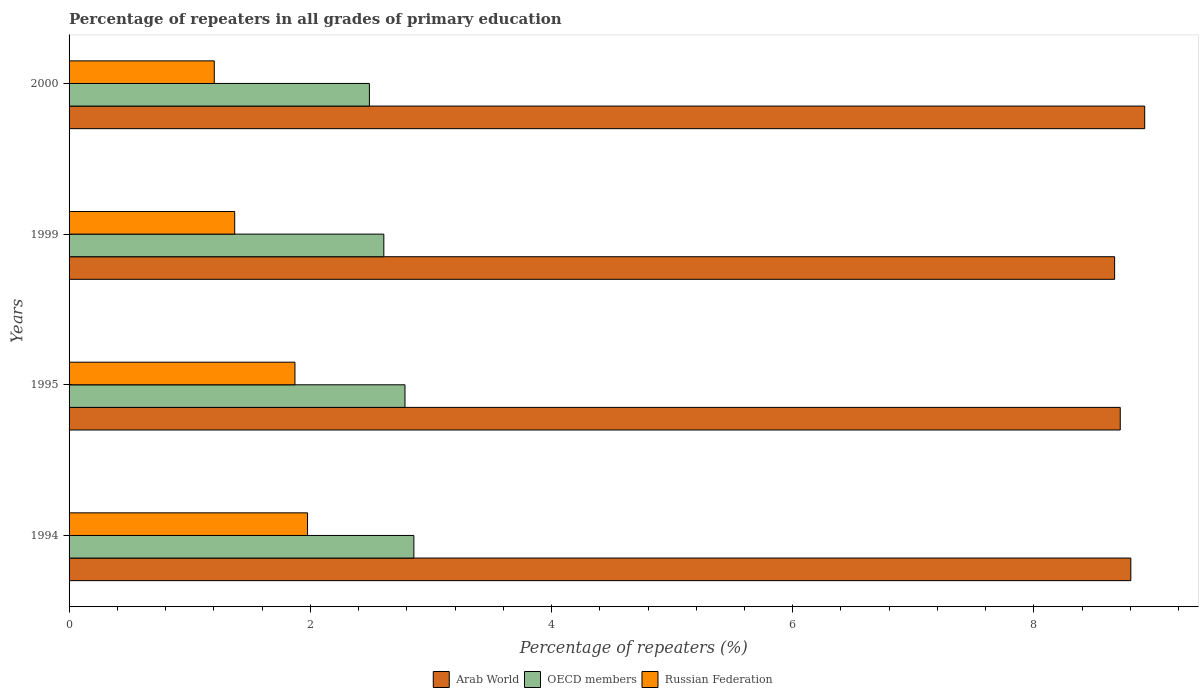How many different coloured bars are there?
Give a very brief answer. 3. Are the number of bars on each tick of the Y-axis equal?
Ensure brevity in your answer.  Yes. How many bars are there on the 1st tick from the top?
Make the answer very short. 3. How many bars are there on the 3rd tick from the bottom?
Provide a succinct answer. 3. In how many cases, is the number of bars for a given year not equal to the number of legend labels?
Give a very brief answer. 0. What is the percentage of repeaters in Arab World in 1995?
Offer a very short reply. 8.72. Across all years, what is the maximum percentage of repeaters in Russian Federation?
Provide a succinct answer. 1.98. Across all years, what is the minimum percentage of repeaters in Arab World?
Ensure brevity in your answer.  8.67. In which year was the percentage of repeaters in Russian Federation maximum?
Your answer should be very brief. 1994. What is the total percentage of repeaters in Russian Federation in the graph?
Make the answer very short. 6.43. What is the difference between the percentage of repeaters in Arab World in 1999 and that in 2000?
Your answer should be compact. -0.25. What is the difference between the percentage of repeaters in Arab World in 2000 and the percentage of repeaters in Russian Federation in 1999?
Make the answer very short. 7.54. What is the average percentage of repeaters in Arab World per year?
Ensure brevity in your answer.  8.78. In the year 2000, what is the difference between the percentage of repeaters in OECD members and percentage of repeaters in Arab World?
Offer a very short reply. -6.43. What is the ratio of the percentage of repeaters in OECD members in 1995 to that in 2000?
Offer a very short reply. 1.12. Is the percentage of repeaters in Russian Federation in 1999 less than that in 2000?
Your response must be concise. No. What is the difference between the highest and the second highest percentage of repeaters in OECD members?
Provide a short and direct response. 0.07. What is the difference between the highest and the lowest percentage of repeaters in Arab World?
Keep it short and to the point. 0.25. In how many years, is the percentage of repeaters in Russian Federation greater than the average percentage of repeaters in Russian Federation taken over all years?
Provide a succinct answer. 2. What does the 1st bar from the top in 1995 represents?
Provide a short and direct response. Russian Federation. What does the 3rd bar from the bottom in 1994 represents?
Your answer should be very brief. Russian Federation. Are all the bars in the graph horizontal?
Your answer should be very brief. Yes. How many years are there in the graph?
Offer a very short reply. 4. Does the graph contain any zero values?
Offer a very short reply. No. Does the graph contain grids?
Make the answer very short. No. Where does the legend appear in the graph?
Ensure brevity in your answer.  Bottom center. How are the legend labels stacked?
Your response must be concise. Horizontal. What is the title of the graph?
Provide a short and direct response. Percentage of repeaters in all grades of primary education. What is the label or title of the X-axis?
Make the answer very short. Percentage of repeaters (%). What is the label or title of the Y-axis?
Provide a succinct answer. Years. What is the Percentage of repeaters (%) of Arab World in 1994?
Provide a succinct answer. 8.8. What is the Percentage of repeaters (%) in OECD members in 1994?
Give a very brief answer. 2.86. What is the Percentage of repeaters (%) in Russian Federation in 1994?
Offer a terse response. 1.98. What is the Percentage of repeaters (%) in Arab World in 1995?
Offer a very short reply. 8.72. What is the Percentage of repeaters (%) of OECD members in 1995?
Provide a succinct answer. 2.79. What is the Percentage of repeaters (%) of Russian Federation in 1995?
Offer a very short reply. 1.87. What is the Percentage of repeaters (%) of Arab World in 1999?
Provide a succinct answer. 8.67. What is the Percentage of repeaters (%) of OECD members in 1999?
Offer a terse response. 2.61. What is the Percentage of repeaters (%) of Russian Federation in 1999?
Ensure brevity in your answer.  1.37. What is the Percentage of repeaters (%) in Arab World in 2000?
Your answer should be compact. 8.92. What is the Percentage of repeaters (%) in OECD members in 2000?
Offer a very short reply. 2.49. What is the Percentage of repeaters (%) of Russian Federation in 2000?
Ensure brevity in your answer.  1.2. Across all years, what is the maximum Percentage of repeaters (%) of Arab World?
Offer a very short reply. 8.92. Across all years, what is the maximum Percentage of repeaters (%) in OECD members?
Give a very brief answer. 2.86. Across all years, what is the maximum Percentage of repeaters (%) in Russian Federation?
Ensure brevity in your answer.  1.98. Across all years, what is the minimum Percentage of repeaters (%) in Arab World?
Keep it short and to the point. 8.67. Across all years, what is the minimum Percentage of repeaters (%) in OECD members?
Your response must be concise. 2.49. Across all years, what is the minimum Percentage of repeaters (%) of Russian Federation?
Provide a short and direct response. 1.2. What is the total Percentage of repeaters (%) of Arab World in the graph?
Ensure brevity in your answer.  35.11. What is the total Percentage of repeaters (%) in OECD members in the graph?
Provide a short and direct response. 10.74. What is the total Percentage of repeaters (%) of Russian Federation in the graph?
Keep it short and to the point. 6.43. What is the difference between the Percentage of repeaters (%) of Arab World in 1994 and that in 1995?
Your answer should be very brief. 0.09. What is the difference between the Percentage of repeaters (%) of OECD members in 1994 and that in 1995?
Your answer should be compact. 0.07. What is the difference between the Percentage of repeaters (%) in Russian Federation in 1994 and that in 1995?
Your response must be concise. 0.1. What is the difference between the Percentage of repeaters (%) in Arab World in 1994 and that in 1999?
Make the answer very short. 0.13. What is the difference between the Percentage of repeaters (%) in OECD members in 1994 and that in 1999?
Provide a short and direct response. 0.25. What is the difference between the Percentage of repeaters (%) of Russian Federation in 1994 and that in 1999?
Provide a succinct answer. 0.6. What is the difference between the Percentage of repeaters (%) of Arab World in 1994 and that in 2000?
Provide a succinct answer. -0.12. What is the difference between the Percentage of repeaters (%) in OECD members in 1994 and that in 2000?
Offer a very short reply. 0.37. What is the difference between the Percentage of repeaters (%) in Russian Federation in 1994 and that in 2000?
Your response must be concise. 0.77. What is the difference between the Percentage of repeaters (%) in Arab World in 1995 and that in 1999?
Your answer should be very brief. 0.05. What is the difference between the Percentage of repeaters (%) of OECD members in 1995 and that in 1999?
Ensure brevity in your answer.  0.18. What is the difference between the Percentage of repeaters (%) in Russian Federation in 1995 and that in 1999?
Give a very brief answer. 0.5. What is the difference between the Percentage of repeaters (%) of Arab World in 1995 and that in 2000?
Keep it short and to the point. -0.2. What is the difference between the Percentage of repeaters (%) of OECD members in 1995 and that in 2000?
Keep it short and to the point. 0.29. What is the difference between the Percentage of repeaters (%) in Russian Federation in 1995 and that in 2000?
Offer a terse response. 0.67. What is the difference between the Percentage of repeaters (%) in Arab World in 1999 and that in 2000?
Your answer should be very brief. -0.25. What is the difference between the Percentage of repeaters (%) in OECD members in 1999 and that in 2000?
Your response must be concise. 0.12. What is the difference between the Percentage of repeaters (%) in Russian Federation in 1999 and that in 2000?
Your answer should be compact. 0.17. What is the difference between the Percentage of repeaters (%) in Arab World in 1994 and the Percentage of repeaters (%) in OECD members in 1995?
Make the answer very short. 6.02. What is the difference between the Percentage of repeaters (%) in Arab World in 1994 and the Percentage of repeaters (%) in Russian Federation in 1995?
Provide a succinct answer. 6.93. What is the difference between the Percentage of repeaters (%) of Arab World in 1994 and the Percentage of repeaters (%) of OECD members in 1999?
Offer a terse response. 6.19. What is the difference between the Percentage of repeaters (%) in Arab World in 1994 and the Percentage of repeaters (%) in Russian Federation in 1999?
Your response must be concise. 7.43. What is the difference between the Percentage of repeaters (%) in OECD members in 1994 and the Percentage of repeaters (%) in Russian Federation in 1999?
Make the answer very short. 1.49. What is the difference between the Percentage of repeaters (%) of Arab World in 1994 and the Percentage of repeaters (%) of OECD members in 2000?
Give a very brief answer. 6.31. What is the difference between the Percentage of repeaters (%) in Arab World in 1994 and the Percentage of repeaters (%) in Russian Federation in 2000?
Give a very brief answer. 7.6. What is the difference between the Percentage of repeaters (%) of OECD members in 1994 and the Percentage of repeaters (%) of Russian Federation in 2000?
Ensure brevity in your answer.  1.65. What is the difference between the Percentage of repeaters (%) of Arab World in 1995 and the Percentage of repeaters (%) of OECD members in 1999?
Your response must be concise. 6.11. What is the difference between the Percentage of repeaters (%) of Arab World in 1995 and the Percentage of repeaters (%) of Russian Federation in 1999?
Offer a terse response. 7.34. What is the difference between the Percentage of repeaters (%) in OECD members in 1995 and the Percentage of repeaters (%) in Russian Federation in 1999?
Your answer should be very brief. 1.41. What is the difference between the Percentage of repeaters (%) in Arab World in 1995 and the Percentage of repeaters (%) in OECD members in 2000?
Provide a short and direct response. 6.23. What is the difference between the Percentage of repeaters (%) of Arab World in 1995 and the Percentage of repeaters (%) of Russian Federation in 2000?
Ensure brevity in your answer.  7.51. What is the difference between the Percentage of repeaters (%) of OECD members in 1995 and the Percentage of repeaters (%) of Russian Federation in 2000?
Provide a short and direct response. 1.58. What is the difference between the Percentage of repeaters (%) in Arab World in 1999 and the Percentage of repeaters (%) in OECD members in 2000?
Provide a succinct answer. 6.18. What is the difference between the Percentage of repeaters (%) of Arab World in 1999 and the Percentage of repeaters (%) of Russian Federation in 2000?
Ensure brevity in your answer.  7.46. What is the difference between the Percentage of repeaters (%) in OECD members in 1999 and the Percentage of repeaters (%) in Russian Federation in 2000?
Keep it short and to the point. 1.41. What is the average Percentage of repeaters (%) of Arab World per year?
Offer a very short reply. 8.78. What is the average Percentage of repeaters (%) of OECD members per year?
Provide a succinct answer. 2.69. What is the average Percentage of repeaters (%) of Russian Federation per year?
Ensure brevity in your answer.  1.61. In the year 1994, what is the difference between the Percentage of repeaters (%) of Arab World and Percentage of repeaters (%) of OECD members?
Your answer should be compact. 5.94. In the year 1994, what is the difference between the Percentage of repeaters (%) of Arab World and Percentage of repeaters (%) of Russian Federation?
Provide a succinct answer. 6.83. In the year 1994, what is the difference between the Percentage of repeaters (%) of OECD members and Percentage of repeaters (%) of Russian Federation?
Provide a succinct answer. 0.88. In the year 1995, what is the difference between the Percentage of repeaters (%) in Arab World and Percentage of repeaters (%) in OECD members?
Keep it short and to the point. 5.93. In the year 1995, what is the difference between the Percentage of repeaters (%) in Arab World and Percentage of repeaters (%) in Russian Federation?
Your answer should be very brief. 6.84. In the year 1995, what is the difference between the Percentage of repeaters (%) of OECD members and Percentage of repeaters (%) of Russian Federation?
Offer a very short reply. 0.91. In the year 1999, what is the difference between the Percentage of repeaters (%) of Arab World and Percentage of repeaters (%) of OECD members?
Ensure brevity in your answer.  6.06. In the year 1999, what is the difference between the Percentage of repeaters (%) in Arab World and Percentage of repeaters (%) in Russian Federation?
Provide a succinct answer. 7.3. In the year 1999, what is the difference between the Percentage of repeaters (%) of OECD members and Percentage of repeaters (%) of Russian Federation?
Make the answer very short. 1.24. In the year 2000, what is the difference between the Percentage of repeaters (%) of Arab World and Percentage of repeaters (%) of OECD members?
Give a very brief answer. 6.43. In the year 2000, what is the difference between the Percentage of repeaters (%) in Arab World and Percentage of repeaters (%) in Russian Federation?
Provide a short and direct response. 7.71. In the year 2000, what is the difference between the Percentage of repeaters (%) of OECD members and Percentage of repeaters (%) of Russian Federation?
Give a very brief answer. 1.29. What is the ratio of the Percentage of repeaters (%) in Arab World in 1994 to that in 1995?
Your answer should be compact. 1.01. What is the ratio of the Percentage of repeaters (%) in OECD members in 1994 to that in 1995?
Your response must be concise. 1.03. What is the ratio of the Percentage of repeaters (%) of Russian Federation in 1994 to that in 1995?
Make the answer very short. 1.06. What is the ratio of the Percentage of repeaters (%) of Arab World in 1994 to that in 1999?
Keep it short and to the point. 1.02. What is the ratio of the Percentage of repeaters (%) in OECD members in 1994 to that in 1999?
Offer a very short reply. 1.1. What is the ratio of the Percentage of repeaters (%) of Russian Federation in 1994 to that in 1999?
Give a very brief answer. 1.44. What is the ratio of the Percentage of repeaters (%) of Arab World in 1994 to that in 2000?
Offer a terse response. 0.99. What is the ratio of the Percentage of repeaters (%) of OECD members in 1994 to that in 2000?
Provide a succinct answer. 1.15. What is the ratio of the Percentage of repeaters (%) in Russian Federation in 1994 to that in 2000?
Offer a terse response. 1.64. What is the ratio of the Percentage of repeaters (%) in Arab World in 1995 to that in 1999?
Your answer should be compact. 1.01. What is the ratio of the Percentage of repeaters (%) of OECD members in 1995 to that in 1999?
Your answer should be compact. 1.07. What is the ratio of the Percentage of repeaters (%) in Russian Federation in 1995 to that in 1999?
Your answer should be very brief. 1.36. What is the ratio of the Percentage of repeaters (%) of Arab World in 1995 to that in 2000?
Provide a succinct answer. 0.98. What is the ratio of the Percentage of repeaters (%) in OECD members in 1995 to that in 2000?
Provide a succinct answer. 1.12. What is the ratio of the Percentage of repeaters (%) in Russian Federation in 1995 to that in 2000?
Your answer should be compact. 1.56. What is the ratio of the Percentage of repeaters (%) of OECD members in 1999 to that in 2000?
Offer a very short reply. 1.05. What is the ratio of the Percentage of repeaters (%) of Russian Federation in 1999 to that in 2000?
Keep it short and to the point. 1.14. What is the difference between the highest and the second highest Percentage of repeaters (%) in Arab World?
Offer a very short reply. 0.12. What is the difference between the highest and the second highest Percentage of repeaters (%) of OECD members?
Offer a terse response. 0.07. What is the difference between the highest and the second highest Percentage of repeaters (%) of Russian Federation?
Your answer should be compact. 0.1. What is the difference between the highest and the lowest Percentage of repeaters (%) of Arab World?
Your answer should be compact. 0.25. What is the difference between the highest and the lowest Percentage of repeaters (%) in OECD members?
Ensure brevity in your answer.  0.37. What is the difference between the highest and the lowest Percentage of repeaters (%) in Russian Federation?
Keep it short and to the point. 0.77. 